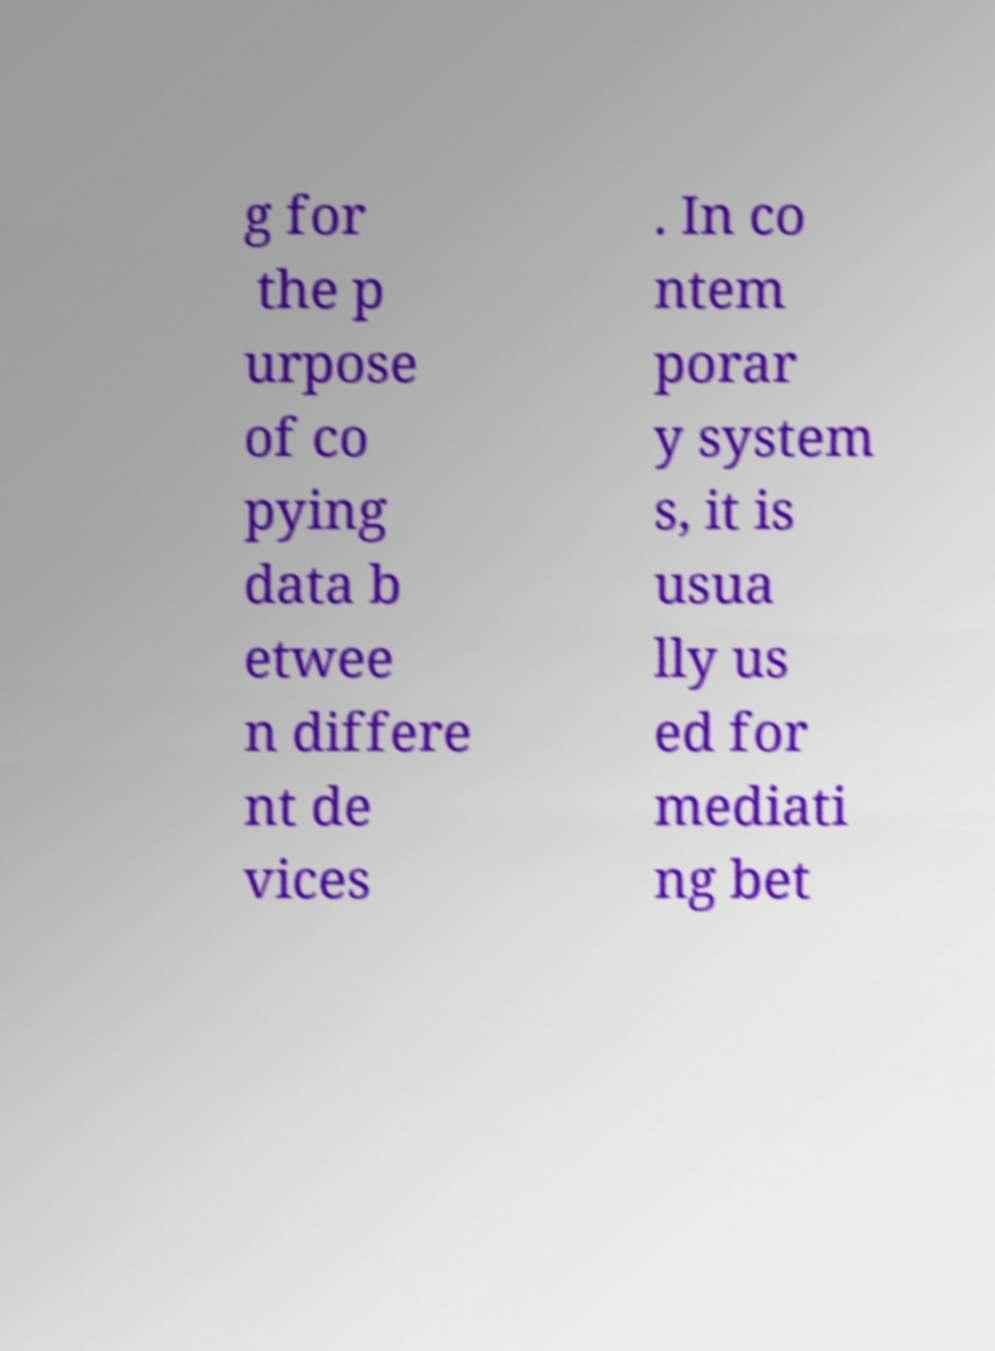Can you read and provide the text displayed in the image?This photo seems to have some interesting text. Can you extract and type it out for me? g for the p urpose of co pying data b etwee n differe nt de vices . In co ntem porar y system s, it is usua lly us ed for mediati ng bet 